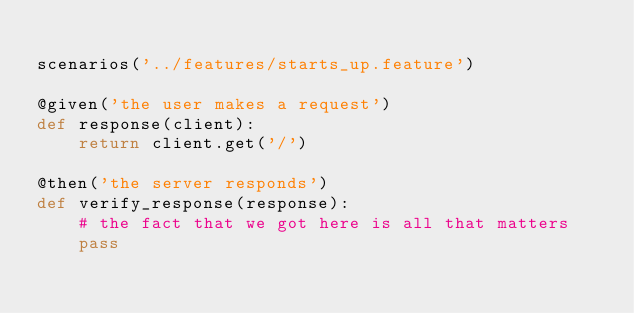<code> <loc_0><loc_0><loc_500><loc_500><_Python_>
scenarios('../features/starts_up.feature')

@given('the user makes a request')
def response(client):
    return client.get('/')

@then('the server responds')
def verify_response(response):
    # the fact that we got here is all that matters
    pass

</code> 